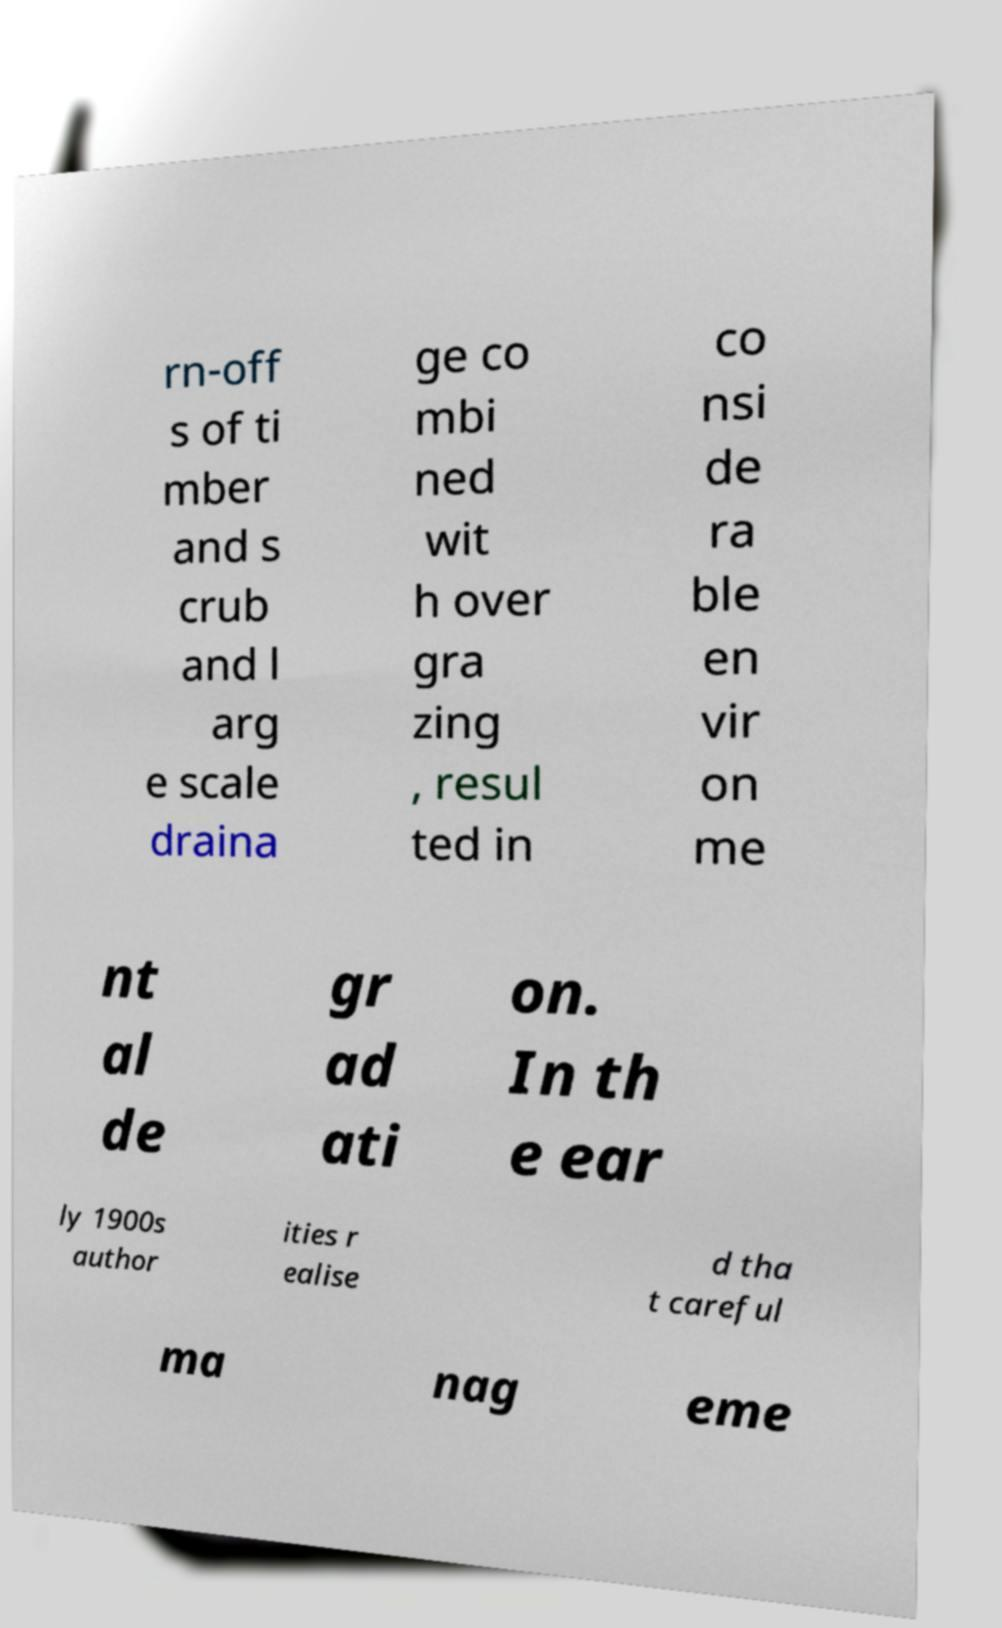Could you extract and type out the text from this image? rn-off s of ti mber and s crub and l arg e scale draina ge co mbi ned wit h over gra zing , resul ted in co nsi de ra ble en vir on me nt al de gr ad ati on. In th e ear ly 1900s author ities r ealise d tha t careful ma nag eme 